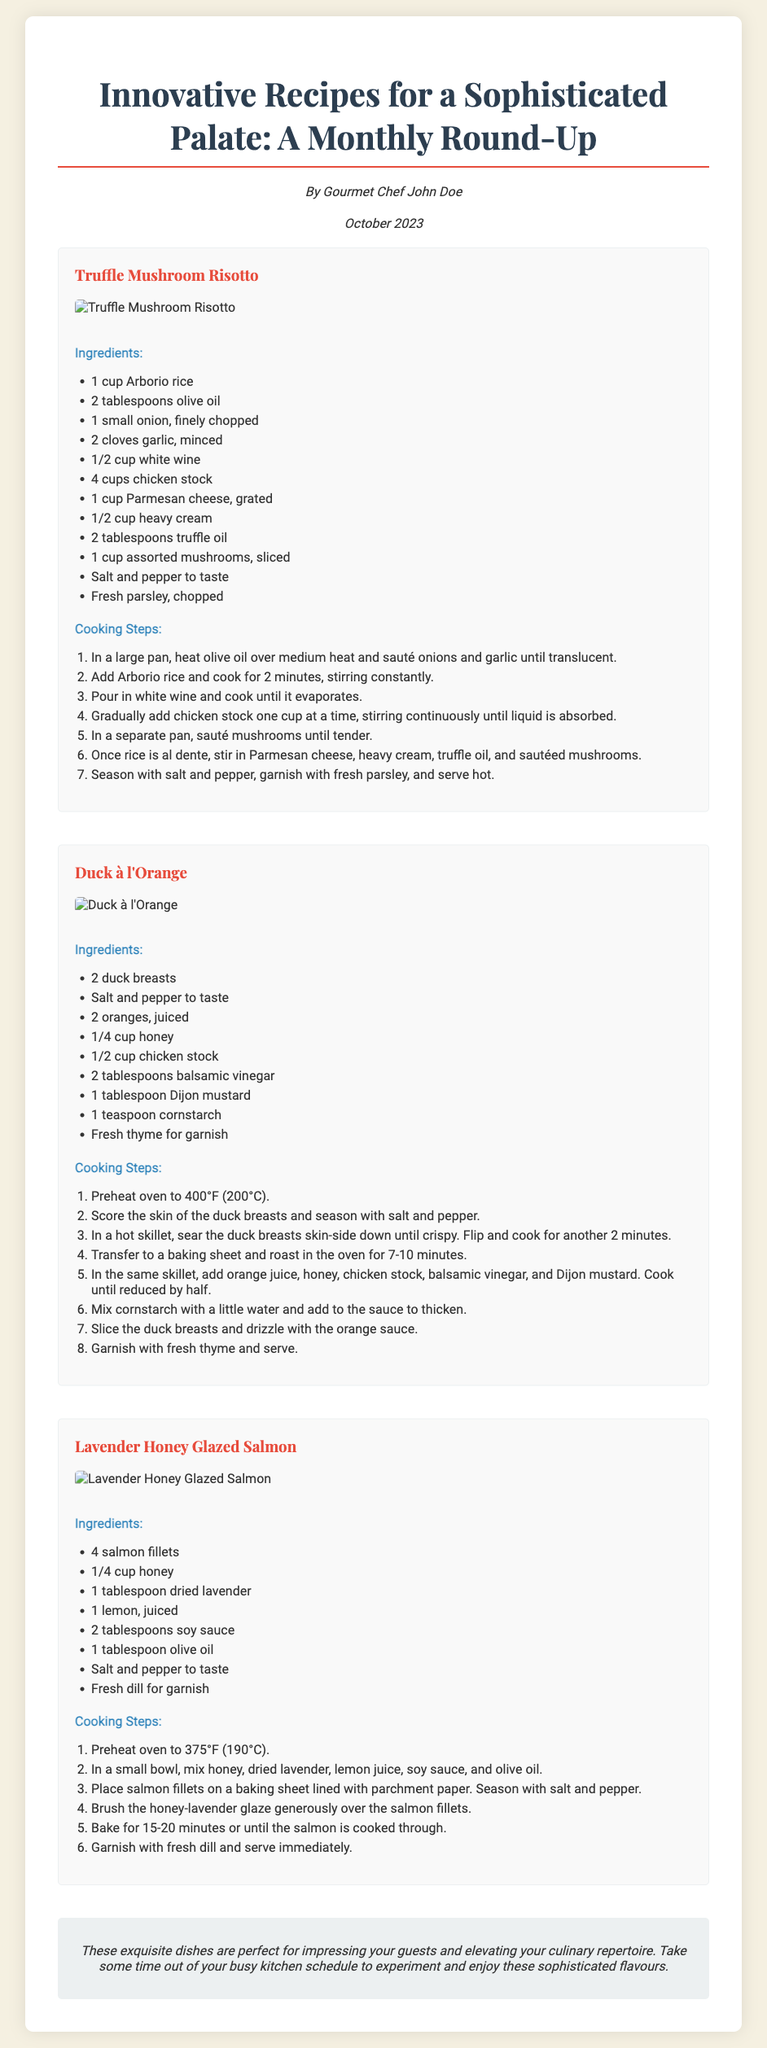What is the title of the Playbill? The title is prominently displayed at the top of the document.
Answer: Innovative Recipes for a Sophisticated Palate: A Monthly Round-Up Who is the author of the document? The author's name is mentioned below the title.
Answer: Gourmet Chef John Doe What is the date of this edition? The date is clearly stated in the document.
Answer: October 2023 How many recipes are included in the document? There are three distinct recipes presented in the document.
Answer: 3 What is the main ingredient in Duck à l'Orange? The recipe specifically highlights duck as its main ingredient.
Answer: Duck What is the cooking temperature for Lavender Honey Glazed Salmon? The cooking temperature is specified in the cooking steps for the salmon recipe.
Answer: 375°F (190°C) Which ingredient is used in both Truffle Mushroom Risotto and Duck à l'Orange? Comparing the ingredients lists for both recipes reveals the common ingredient.
Answer: Salt and pepper What should you garnish the Lavender Honey Glazed Salmon with? The garnish is clearly specified in the cooking steps section of the salmon recipe.
Answer: Fresh dill What image is associated with Duck à l'Orange? The image link is provided alongside the recipe within the document.
Answer: https://example.com/images/duck-a-lorange.jpg 